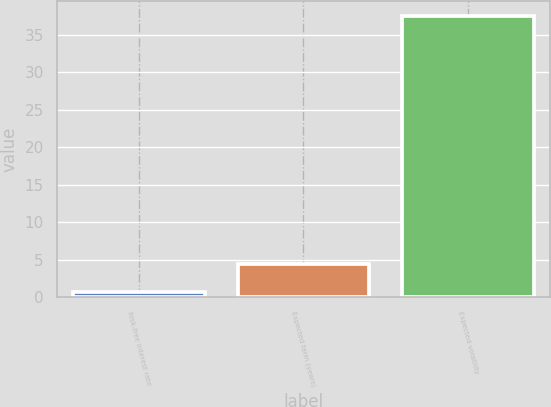<chart> <loc_0><loc_0><loc_500><loc_500><bar_chart><fcel>Risk-free interest rate<fcel>Expected term (years)<fcel>Expected volatility<nl><fcel>0.75<fcel>4.43<fcel>37.53<nl></chart> 